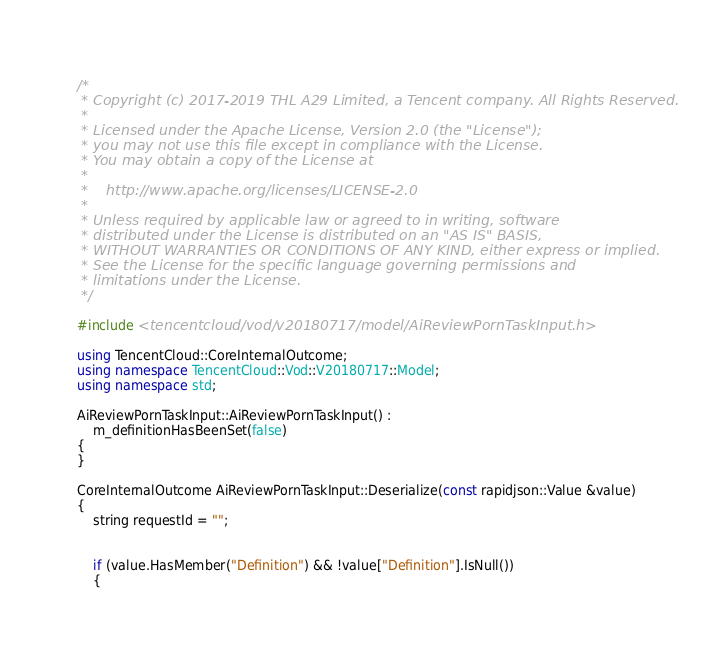<code> <loc_0><loc_0><loc_500><loc_500><_C++_>/*
 * Copyright (c) 2017-2019 THL A29 Limited, a Tencent company. All Rights Reserved.
 *
 * Licensed under the Apache License, Version 2.0 (the "License");
 * you may not use this file except in compliance with the License.
 * You may obtain a copy of the License at
 *
 *    http://www.apache.org/licenses/LICENSE-2.0
 *
 * Unless required by applicable law or agreed to in writing, software
 * distributed under the License is distributed on an "AS IS" BASIS,
 * WITHOUT WARRANTIES OR CONDITIONS OF ANY KIND, either express or implied.
 * See the License for the specific language governing permissions and
 * limitations under the License.
 */

#include <tencentcloud/vod/v20180717/model/AiReviewPornTaskInput.h>

using TencentCloud::CoreInternalOutcome;
using namespace TencentCloud::Vod::V20180717::Model;
using namespace std;

AiReviewPornTaskInput::AiReviewPornTaskInput() :
    m_definitionHasBeenSet(false)
{
}

CoreInternalOutcome AiReviewPornTaskInput::Deserialize(const rapidjson::Value &value)
{
    string requestId = "";


    if (value.HasMember("Definition") && !value["Definition"].IsNull())
    {</code> 